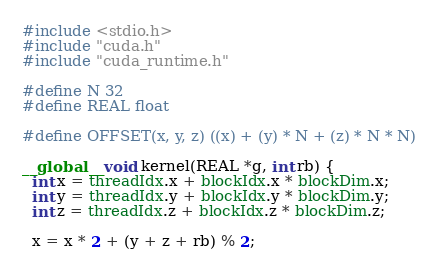<code> <loc_0><loc_0><loc_500><loc_500><_Cuda_>#include <stdio.h>
#include "cuda.h"
#include "cuda_runtime.h"

#define N 32
#define REAL float

#define OFFSET(x, y, z) ((x) + (y) * N + (z) * N * N)

__global__ void kernel(REAL *g, int rb) {
  int x = threadIdx.x + blockIdx.x * blockDim.x;
  int y = threadIdx.y + blockIdx.y * blockDim.y;
  int z = threadIdx.z + blockIdx.z * blockDim.z;

  x = x * 2 + (y + z + rb) % 2;
</code> 